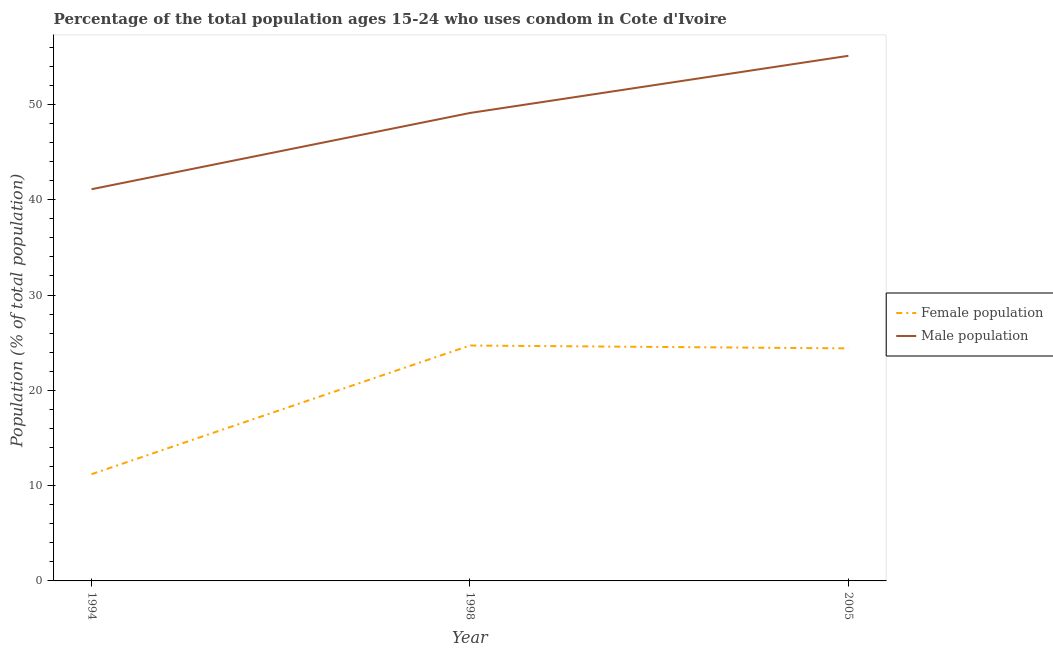Does the line corresponding to male population intersect with the line corresponding to female population?
Your response must be concise. No. What is the male population in 1998?
Offer a very short reply. 49.1. Across all years, what is the maximum female population?
Provide a succinct answer. 24.7. In which year was the male population minimum?
Provide a succinct answer. 1994. What is the total male population in the graph?
Offer a very short reply. 145.3. What is the difference between the male population in 1994 and that in 2005?
Your answer should be compact. -14. What is the difference between the female population in 2005 and the male population in 1998?
Give a very brief answer. -24.7. What is the average female population per year?
Make the answer very short. 20.1. In the year 1994, what is the difference between the male population and female population?
Provide a short and direct response. 29.9. In how many years, is the male population greater than 14 %?
Provide a short and direct response. 3. What is the ratio of the male population in 1994 to that in 2005?
Keep it short and to the point. 0.75. Is the difference between the male population in 1994 and 2005 greater than the difference between the female population in 1994 and 2005?
Provide a short and direct response. No. What is the difference between the highest and the second highest male population?
Provide a short and direct response. 6. What is the difference between the highest and the lowest male population?
Keep it short and to the point. 14. Is the sum of the male population in 1998 and 2005 greater than the maximum female population across all years?
Give a very brief answer. Yes. Does the female population monotonically increase over the years?
Provide a succinct answer. No. How many lines are there?
Give a very brief answer. 2. Does the graph contain grids?
Provide a short and direct response. No. Where does the legend appear in the graph?
Provide a succinct answer. Center right. How many legend labels are there?
Provide a short and direct response. 2. What is the title of the graph?
Offer a terse response. Percentage of the total population ages 15-24 who uses condom in Cote d'Ivoire. What is the label or title of the X-axis?
Keep it short and to the point. Year. What is the label or title of the Y-axis?
Your answer should be compact. Population (% of total population) . What is the Population (% of total population)  in Female population in 1994?
Offer a very short reply. 11.2. What is the Population (% of total population)  of Male population in 1994?
Offer a terse response. 41.1. What is the Population (% of total population)  in Female population in 1998?
Offer a very short reply. 24.7. What is the Population (% of total population)  of Male population in 1998?
Keep it short and to the point. 49.1. What is the Population (% of total population)  in Female population in 2005?
Provide a succinct answer. 24.4. What is the Population (% of total population)  of Male population in 2005?
Offer a terse response. 55.1. Across all years, what is the maximum Population (% of total population)  in Female population?
Keep it short and to the point. 24.7. Across all years, what is the maximum Population (% of total population)  of Male population?
Make the answer very short. 55.1. Across all years, what is the minimum Population (% of total population)  in Male population?
Provide a short and direct response. 41.1. What is the total Population (% of total population)  of Female population in the graph?
Provide a short and direct response. 60.3. What is the total Population (% of total population)  in Male population in the graph?
Offer a very short reply. 145.3. What is the difference between the Population (% of total population)  of Female population in 1994 and that in 1998?
Your answer should be very brief. -13.5. What is the difference between the Population (% of total population)  in Male population in 1994 and that in 2005?
Make the answer very short. -14. What is the difference between the Population (% of total population)  of Female population in 1998 and that in 2005?
Provide a short and direct response. 0.3. What is the difference between the Population (% of total population)  in Female population in 1994 and the Population (% of total population)  in Male population in 1998?
Your answer should be compact. -37.9. What is the difference between the Population (% of total population)  of Female population in 1994 and the Population (% of total population)  of Male population in 2005?
Offer a very short reply. -43.9. What is the difference between the Population (% of total population)  of Female population in 1998 and the Population (% of total population)  of Male population in 2005?
Your response must be concise. -30.4. What is the average Population (% of total population)  of Female population per year?
Make the answer very short. 20.1. What is the average Population (% of total population)  of Male population per year?
Provide a short and direct response. 48.43. In the year 1994, what is the difference between the Population (% of total population)  in Female population and Population (% of total population)  in Male population?
Provide a short and direct response. -29.9. In the year 1998, what is the difference between the Population (% of total population)  of Female population and Population (% of total population)  of Male population?
Offer a terse response. -24.4. In the year 2005, what is the difference between the Population (% of total population)  of Female population and Population (% of total population)  of Male population?
Give a very brief answer. -30.7. What is the ratio of the Population (% of total population)  of Female population in 1994 to that in 1998?
Provide a short and direct response. 0.45. What is the ratio of the Population (% of total population)  of Male population in 1994 to that in 1998?
Your response must be concise. 0.84. What is the ratio of the Population (% of total population)  of Female population in 1994 to that in 2005?
Provide a short and direct response. 0.46. What is the ratio of the Population (% of total population)  in Male population in 1994 to that in 2005?
Your answer should be compact. 0.75. What is the ratio of the Population (% of total population)  of Female population in 1998 to that in 2005?
Give a very brief answer. 1.01. What is the ratio of the Population (% of total population)  in Male population in 1998 to that in 2005?
Give a very brief answer. 0.89. What is the difference between the highest and the second highest Population (% of total population)  in Female population?
Ensure brevity in your answer.  0.3. What is the difference between the highest and the second highest Population (% of total population)  of Male population?
Offer a terse response. 6. What is the difference between the highest and the lowest Population (% of total population)  in Female population?
Give a very brief answer. 13.5. What is the difference between the highest and the lowest Population (% of total population)  of Male population?
Your answer should be very brief. 14. 